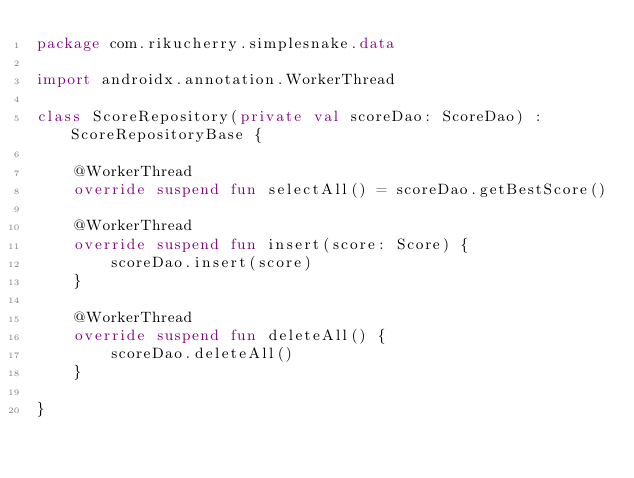<code> <loc_0><loc_0><loc_500><loc_500><_Kotlin_>package com.rikucherry.simplesnake.data

import androidx.annotation.WorkerThread

class ScoreRepository(private val scoreDao: ScoreDao) : ScoreRepositoryBase {

    @WorkerThread
    override suspend fun selectAll() = scoreDao.getBestScore()

    @WorkerThread
    override suspend fun insert(score: Score) {
        scoreDao.insert(score)
    }

    @WorkerThread
    override suspend fun deleteAll() {
        scoreDao.deleteAll()
    }

}</code> 